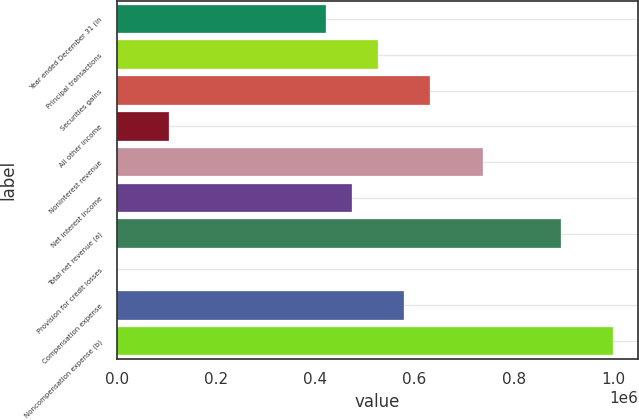Convert chart. <chart><loc_0><loc_0><loc_500><loc_500><bar_chart><fcel>Year ended December 31 (in<fcel>Principal transactions<fcel>Securities gains<fcel>All other income<fcel>Noninterest revenue<fcel>Net interest income<fcel>Total net revenue (a)<fcel>Provision for credit losses<fcel>Compensation expense<fcel>Noncompensation expense (b)<nl><fcel>421248<fcel>526556<fcel>631864<fcel>105322<fcel>737173<fcel>473902<fcel>895135<fcel>14<fcel>579210<fcel>1.00044e+06<nl></chart> 